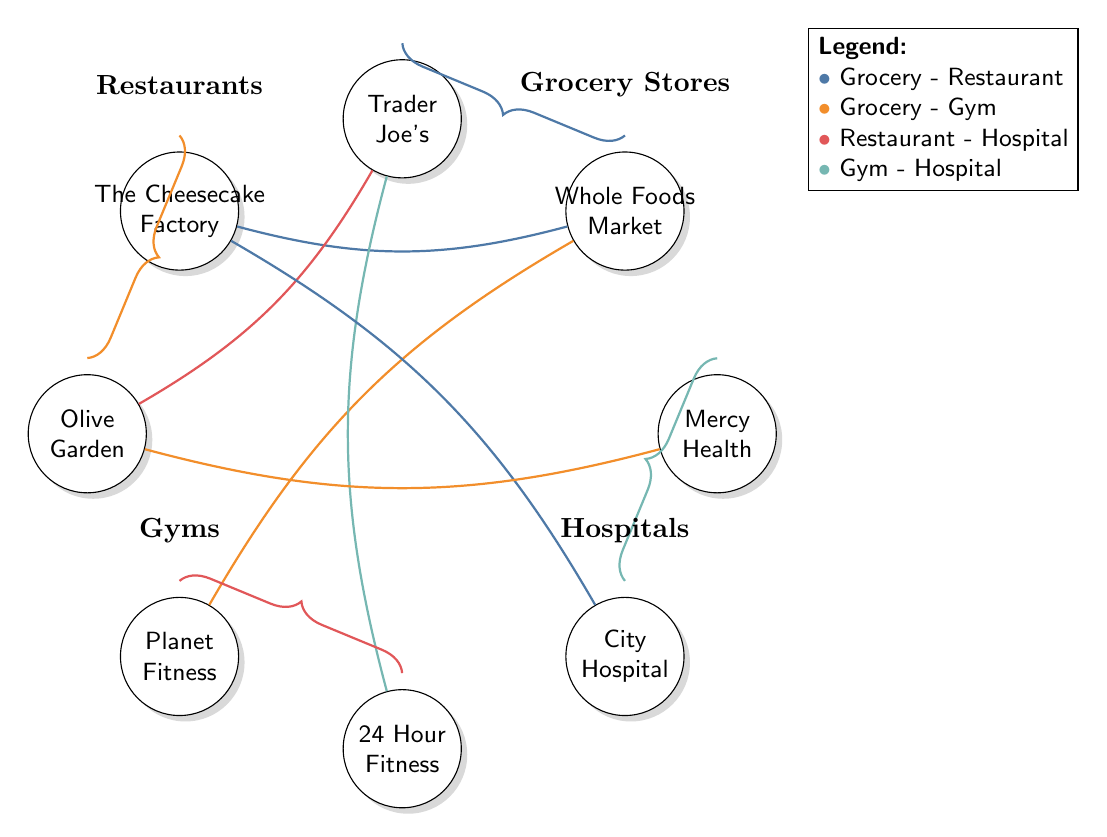What are the two grocery stores depicted in the diagram? The diagram shows two grocery stores: Whole Foods Market and Trader Joe's. They are represented as nodes in the "Grocery Stores" section.
Answer: Whole Foods Market, Trader Joe's Which restaurant is connected to Whole Foods Market? The link from Whole Foods Market connects it to The Cheesecake Factory, which is identified as a restaurant in the diagram.
Answer: The Cheesecake Factory How many gyms are listed in the diagram? There are two gyms mentioned: Planet Fitness and 24 Hour Fitness. Each gym is represented as a separate node in the "Gyms" section of the diagram.
Answer: 2 What type of relationship connects Trader Joe's and Olive Garden? The relationship between Trader Joe's and Olive Garden is categorized as Grocery - Restaurant, indicating that they are connected through a grocery store to a restaurant.
Answer: Grocery - Restaurant Which hospital is associated with The Cheesecake Factory? The Cheesecake Factory is linked to City Hospital, indicating a connection between the restaurant and the hospital in the diagram.
Answer: City Hospital What is the total number of nodes in the diagram? The total count of nodes includes all grocery stores, restaurants, gyms, and hospitals, which sums up to eight nodes in total, according to the diagram's data.
Answer: 8 Which gym has a connection to Trader Joe's? Trader Joe's has a connection to 24 Hour Fitness, which indicates the relationship between this grocery store and the gym in the diagram.
Answer: 24 Hour Fitness How many restaurant-hospital connections are shown? The diagram shows two connections between restaurants and hospitals: The Cheesecake Factory to City Hospital and Olive Garden to Mercy Health, indicating two distinct relationships.
Answer: 2 What color represents the connection between gyms and hospitals? The connection between gyms and hospitals is represented in color four, which is indicated in the legend of the diagram where it specifies the color coding.
Answer: Color four 